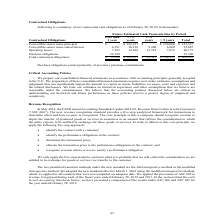According to Calamp's financial document, What does purchase obligations consist primarily of? inventory purchase commitments. The document states: "Purchase obligations consist primarily of inventory purchase commitments...." Also, What were the total Operating Leases?  According to the financial document, 40,177 (in thousands). The relevant text states: "32,887 Operating leases 7,565 12,628 12,325 7,659 40,177 Purchase obligations 39,390 - - - 39,390 Total contractual obligations $ 53,546 $ 145,351 $ 21,525..." Also, What were the total Purchase Obligations? According to the financial document, 39,390 (in thousands). The relevant text states: "5 12,628 12,325 7,659 40,177 Purchase obligations 39,390 - - - 39,390 Total contractual obligations $ 53,546 $ 145,351 $ 21,525 $ 244,559 $ 464,981..." Also, can you calculate: How much do the top 3 contractual obligation terms add up to? Based on the calculation: (352,527+40,177+39,390), the result is 432094 (in thousands). This is based on the information: "32,887 Operating leases 7,565 12,628 12,325 7,659 40,177 Purchase obligations 39,390 - - - 39,390 Total contractual obligations $ 53,546 $ 145,351 $ 21,525 ior notes principal $ - $ 122,527 $ - $ 230,..." The key data points involved are: 352,527, 39,390, 40,177. Also, can you calculate: What are the Operating Leases as a percentage of the total contractual obligations?  Based on the calculation: (40,177/464,981), the result is 8.64 (percentage). This is based on the information: "32,887 Operating leases 7,565 12,628 12,325 7,659 40,177 Purchase obligations 39,390 - - - 39,390 Total contractual obligations $ 53,546 $ 145,351 $ 21,525 ligations $ 53,546 $ 145,351 $ 21,525 $ 244,..." The key data points involved are: 40,177, 464,981. Also, can you calculate: What are the Purchase Obligations as a percentage of the total contractual obligations?  Based on the calculation: (39,390/464,981), the result is 8.47 (percentage). This is based on the information: "ligations $ 53,546 $ 145,351 $ 21,525 $ 244,559 $ 464,981 5 12,628 12,325 7,659 40,177 Purchase obligations 39,390 - - - 39,390 Total contractual obligations $ 53,546 $ 145,351 $ 21,525 $ 244,559 $ 46..." The key data points involved are: 39,390, 464,981. 